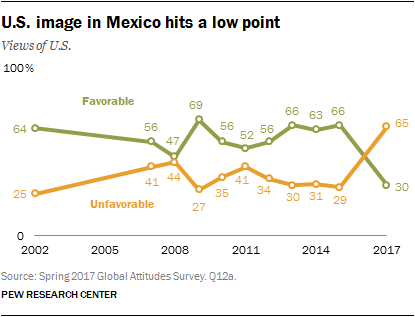What do the trends in the graph suggest about the U.S. image in Mexico from 2002 to 2017? The graph suggests that the perception of the U.S in Mexico has seen significant fluctuations between 2002 and 2017. It started with a high favorable rating of 64% in 2002 but faced a sharp decline to 41% by 2008. Post 2008, the image recovered somewhat, and although there were ups and downs, it ended slightly lower in 2017 with a favorable rating of 65%. Unfavorable ratings mirrored this, peaking at 35% and falling to 30% by 2017. These changes could reflect political, economic, and social events impacting Mexico-U.S. relations over these years. 